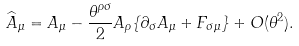Convert formula to latex. <formula><loc_0><loc_0><loc_500><loc_500>\widehat { A } _ { \mu } = A _ { \mu } - \frac { \theta ^ { \rho \sigma } } { 2 } A _ { \rho } \{ \partial _ { \sigma } A _ { \mu } + F _ { \sigma \mu } \} + O ( \theta ^ { 2 } ) .</formula> 